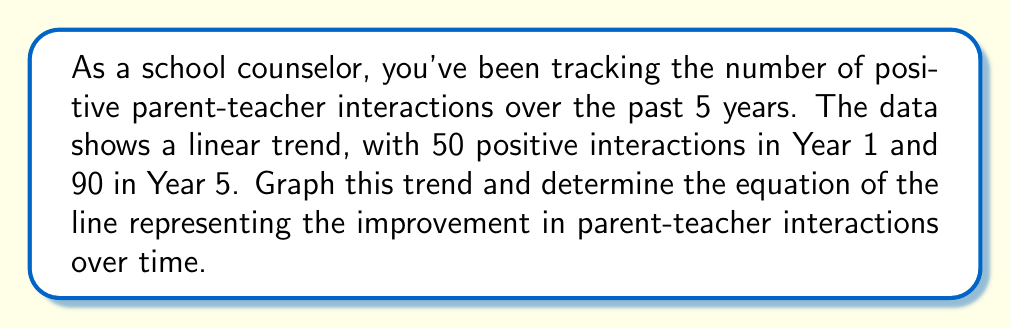Provide a solution to this math problem. 1) First, let's identify our points:
   Year 1: (1, 50)
   Year 5: (5, 90)

2) To find the slope (m) of the line:
   $m = \frac{y_2 - y_1}{x_2 - x_1} = \frac{90 - 50}{5 - 1} = \frac{40}{4} = 10$

3) The slope is 10, meaning the number of positive interactions increases by 10 each year.

4) Now, let's use the point-slope form of a line: $y - y_1 = m(x - x_1)$
   Using (1, 50) as our point: $y - 50 = 10(x - 1)$

5) Simplify to slope-intercept form:
   $y - 50 = 10x - 10$
   $y = 10x - 10 + 50$
   $y = 10x + 40$

6) To graph:
   - y-intercept is at (0, 40)
   - Plot additional points: (1, 50), (2, 60), (3, 70), (4, 80), (5, 90)
   - Connect these points with a straight line

[asy]
size(200,200);
import graph;

xaxis("Years",0,6,arrow=Arrow);
yaxis("Positive Interactions",0,100,arrow=Arrow);

draw((0,40)--(6,100),blue);

dot((1,50));
dot((5,90));

label("(1,50)",(1,50),SE);
label("(5,90)",(5,90),NW);
[/asy]
Answer: $y = 10x + 40$ 